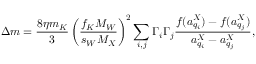Convert formula to latex. <formula><loc_0><loc_0><loc_500><loc_500>\Delta m = \frac { 8 \eta m _ { K } } { 3 } \left ( \frac { f _ { K } M _ { W } } { s _ { W } M _ { X } } \right ) ^ { 2 } \sum _ { i , j } \Gamma _ { i } \Gamma _ { j } \frac { f ( a _ { q _ { i } } ^ { X } ) - f ( a _ { q _ { j } } ^ { X } ) } { a _ { q _ { i } } ^ { X } - a _ { q _ { j } } ^ { X } } ,</formula> 